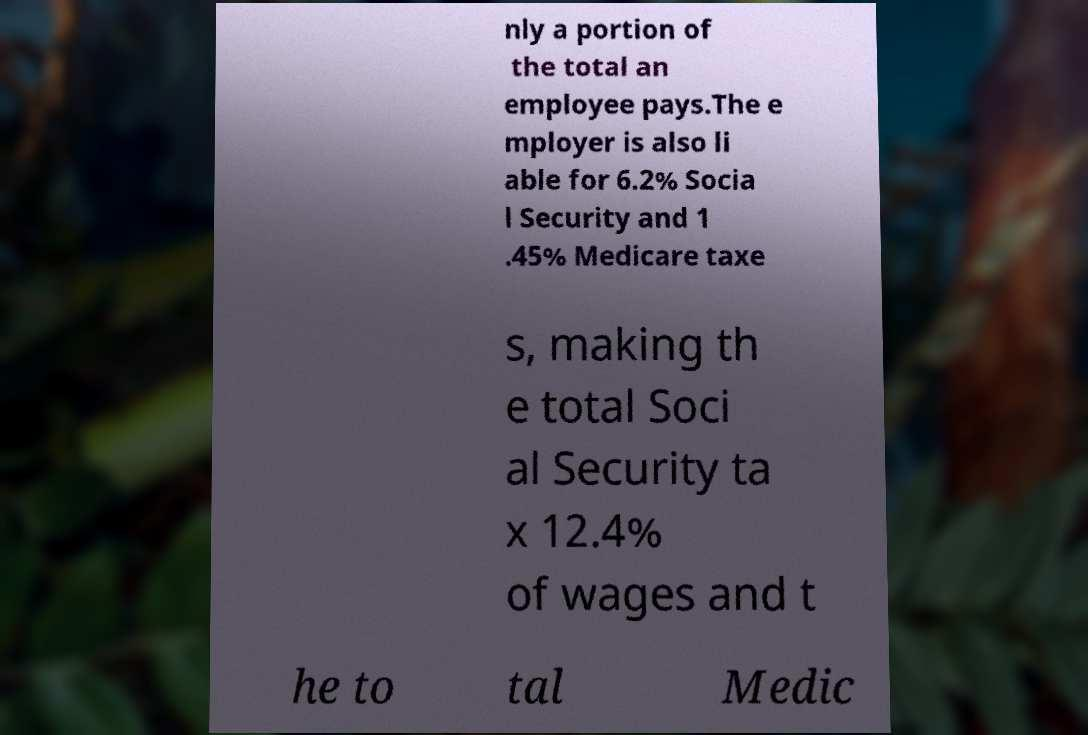For documentation purposes, I need the text within this image transcribed. Could you provide that? nly a portion of the total an employee pays.The e mployer is also li able for 6.2% Socia l Security and 1 .45% Medicare taxe s, making th e total Soci al Security ta x 12.4% of wages and t he to tal Medic 